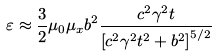Convert formula to latex. <formula><loc_0><loc_0><loc_500><loc_500>\varepsilon \approx \frac { 3 } { 2 } \mu _ { 0 } \mu _ { x } b ^ { 2 } \frac { c ^ { 2 } \gamma ^ { 2 } t } { \left [ c ^ { 2 } \gamma ^ { 2 } t ^ { 2 } + b ^ { 2 } \right ] ^ { 5 / 2 } }</formula> 